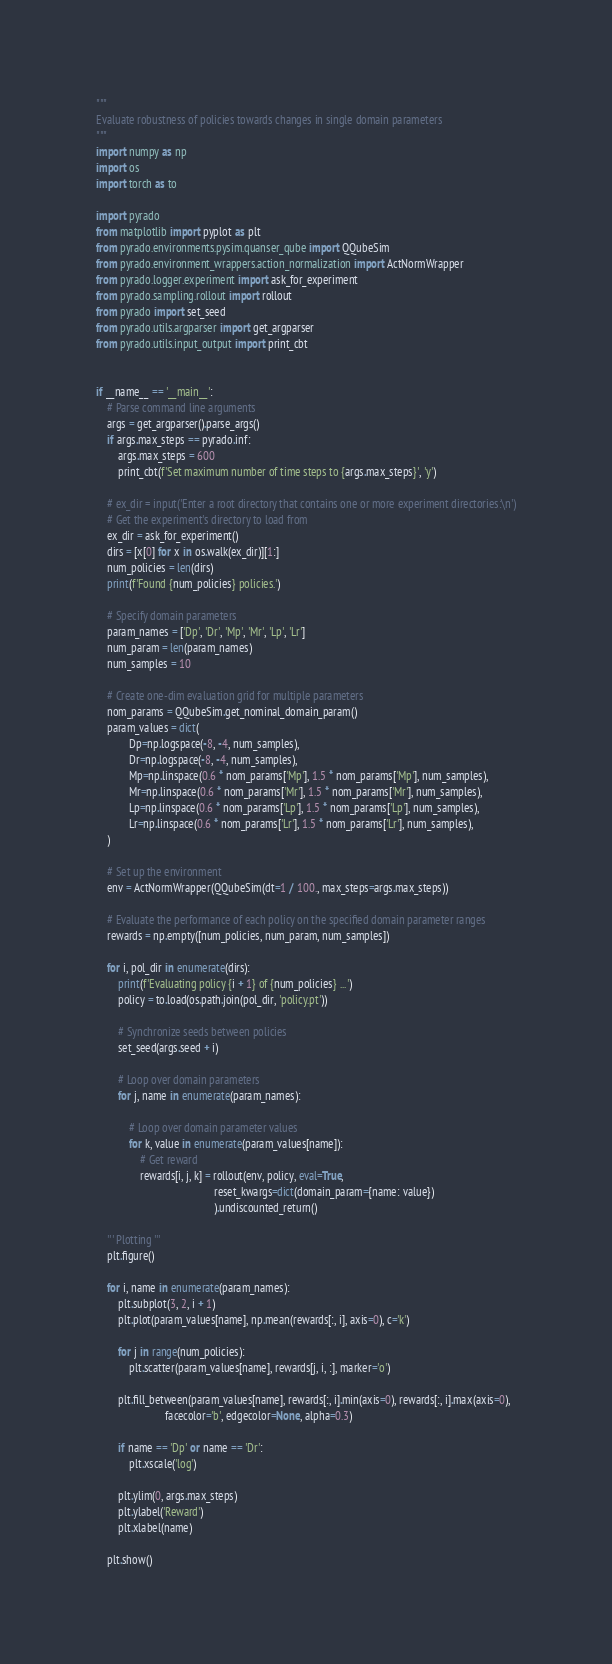Convert code to text. <code><loc_0><loc_0><loc_500><loc_500><_Python_>"""
Evaluate robustness of policies towards changes in single domain parameters
"""
import numpy as np
import os
import torch as to

import pyrado
from matplotlib import pyplot as plt
from pyrado.environments.pysim.quanser_qube import QQubeSim
from pyrado.environment_wrappers.action_normalization import ActNormWrapper
from pyrado.logger.experiment import ask_for_experiment
from pyrado.sampling.rollout import rollout
from pyrado import set_seed
from pyrado.utils.argparser import get_argparser
from pyrado.utils.input_output import print_cbt


if __name__ == '__main__':
    # Parse command line arguments
    args = get_argparser().parse_args()
    if args.max_steps == pyrado.inf:
        args.max_steps = 600
        print_cbt(f'Set maximum number of time steps to {args.max_steps}', 'y')

    # ex_dir = input('Enter a root directory that contains one or more experiment directories:\n')
    # Get the experiment's directory to load from
    ex_dir = ask_for_experiment()
    dirs = [x[0] for x in os.walk(ex_dir)][1:]
    num_policies = len(dirs)
    print(f'Found {num_policies} policies.')

    # Specify domain parameters
    param_names = ['Dp', 'Dr', 'Mp', 'Mr', 'Lp', 'Lr']
    num_param = len(param_names)
    num_samples = 10

    # Create one-dim evaluation grid for multiple parameters
    nom_params = QQubeSim.get_nominal_domain_param()
    param_values = dict(
            Dp=np.logspace(-8, -4, num_samples),
            Dr=np.logspace(-8, -4, num_samples),
            Mp=np.linspace(0.6 * nom_params['Mp'], 1.5 * nom_params['Mp'], num_samples),
            Mr=np.linspace(0.6 * nom_params['Mr'], 1.5 * nom_params['Mr'], num_samples),
            Lp=np.linspace(0.6 * nom_params['Lp'], 1.5 * nom_params['Lp'], num_samples),
            Lr=np.linspace(0.6 * nom_params['Lr'], 1.5 * nom_params['Lr'], num_samples),
    )

    # Set up the environment
    env = ActNormWrapper(QQubeSim(dt=1 / 100., max_steps=args.max_steps))

    # Evaluate the performance of each policy on the specified domain parameter ranges
    rewards = np.empty([num_policies, num_param, num_samples])

    for i, pol_dir in enumerate(dirs):
        print(f'Evaluating policy {i + 1} of {num_policies} ...')
        policy = to.load(os.path.join(pol_dir, 'policy.pt'))

        # Synchronize seeds between policies
        set_seed(args.seed + i)

        # Loop over domain parameters
        for j, name in enumerate(param_names):

            # Loop over domain parameter values
            for k, value in enumerate(param_values[name]):
                # Get reward
                rewards[i, j, k] = rollout(env, policy, eval=True,
                                           reset_kwargs=dict(domain_param={name: value})
                                           ).undiscounted_return()

    ''' Plotting '''
    plt.figure()

    for i, name in enumerate(param_names):
        plt.subplot(3, 2, i + 1)
        plt.plot(param_values[name], np.mean(rewards[:, i], axis=0), c='k')

        for j in range(num_policies):
            plt.scatter(param_values[name], rewards[j, i, :], marker='o')

        plt.fill_between(param_values[name], rewards[:, i].min(axis=0), rewards[:, i].max(axis=0),
                         facecolor='b', edgecolor=None, alpha=0.3)

        if name == 'Dp' or name == 'Dr':
            plt.xscale('log')

        plt.ylim(0, args.max_steps)
        plt.ylabel('Reward')
        plt.xlabel(name)

    plt.show()
</code> 